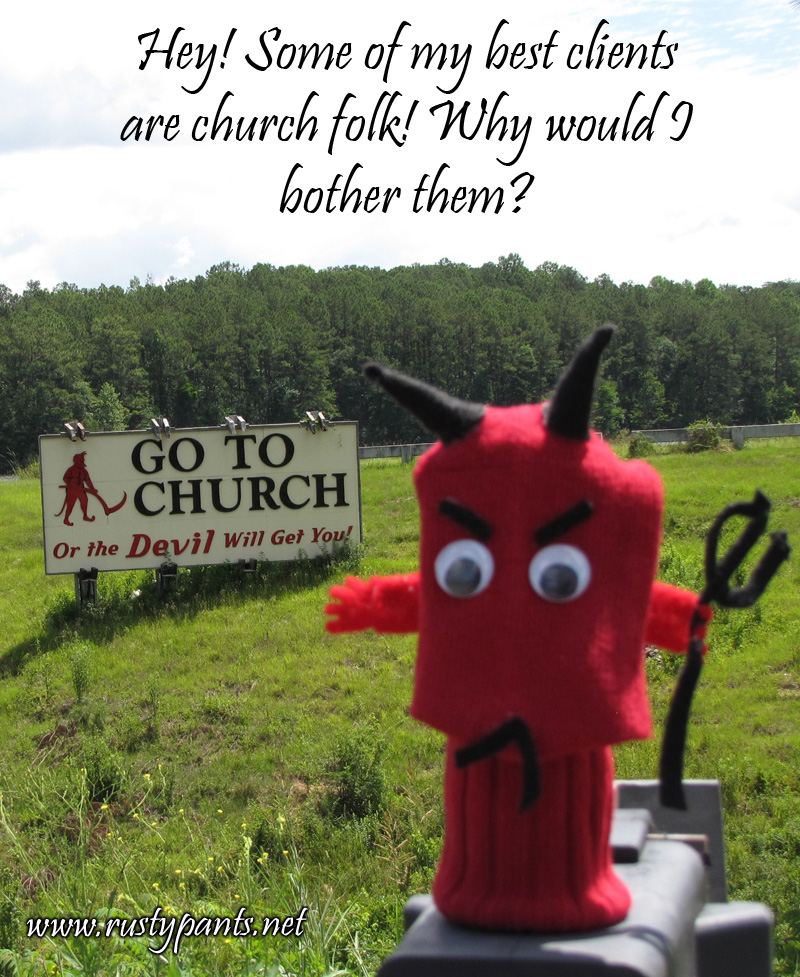What time of day does the lighting in the photograph suggest the picture was taken? The lighting in the image suggests it was taken around midday or early afternoon. Analyzing the shadows under the sign and the general brightness of the scene, the light source appears to be high in the sky indicative of a time shortly after noon. The absence of elongated shadows, which are typical in early morning or late afternoon, and the bright, clear sky confirm this daytime estimate. This observation can help further appreciation of the vivid colors and details of the photograph captured at this time. 